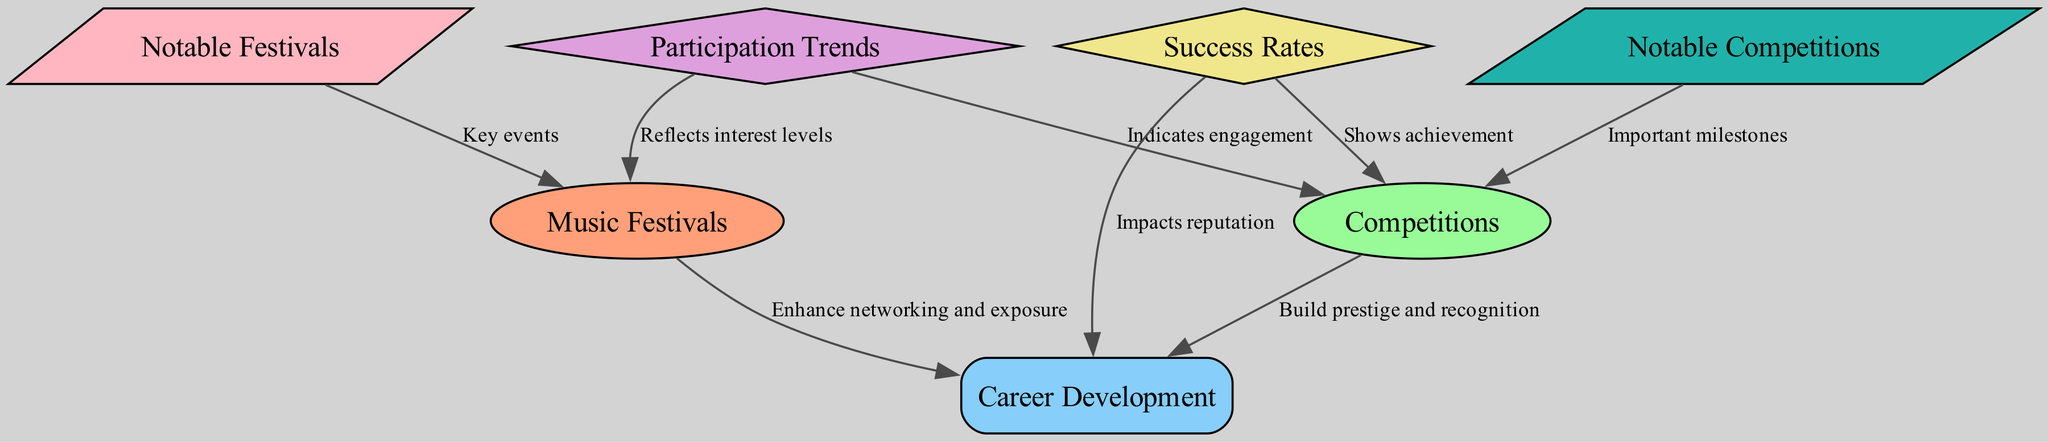What are the key types of events illustrated in the diagram? The diagram shows nodes for music festivals and competitions as key types of events. These nodes are representative of venues where classical guitarists can showcase their talents.
Answer: music festivals, competitions How many nodes are present in the diagram? By counting the circles and rectangles representing the various concepts, there are a total of 7 nodes in the diagram.
Answer: 7 Which node is associated with enhancing networking and exposure? The edge labeled "Enhance networking and exposure" connects music festivals to career development, indicating this relationship.
Answer: music festivals What is the relationship between success rates and competitions? The edge indicates that success rates show achievement within competitions, highlighting a direct relationship in terms of measuring performance.
Answer: Shows achievement Which notable competition is mentioned in the diagram? The diagram refers to notable competitions such as the Guitar Foundation of America Competition and the Parkening International Guitar Competition.
Answer: Guitar Foundation of America Competition How do participation trends impact music festivals? The edge from participation trends to music festivals indicates that these trends reflect interest levels among participants, showing how engagement may vary based on interest.
Answer: Reflects interest levels Is there a connection between success rates and career development? Yes, the edge indicates that success rates impact reputation, which is a crucial aspect of career development for classical guitarists.
Answer: Impacts reputation Can you name one notable festival listed in the diagram? Among the notable festivals mentioned are the GFA Convention and the IGF, denoting significant events in the classical guitar circuit.
Answer: GFA Convention What do participation trends indicate regarding competitions? The edge shows that participation trends indicate engagement in competitions, reflecting how often guitarists compete at various levels.
Answer: Indicates engagement 